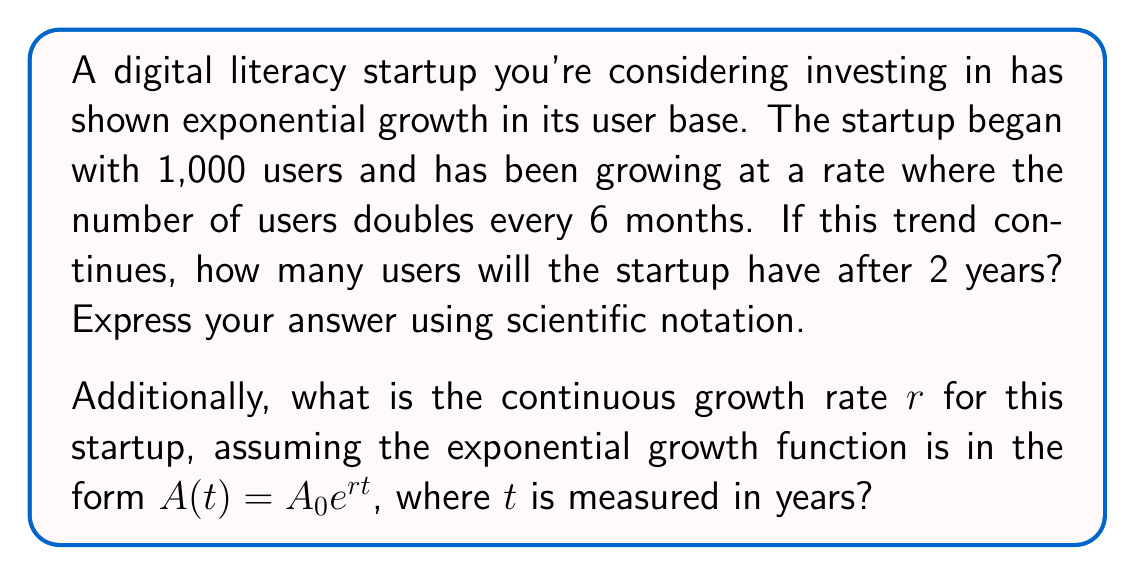Show me your answer to this math problem. Let's approach this problem step by step:

1) First, let's calculate the number of users after 2 years:
   - The number of users doubles every 6 months
   - In 2 years, there are 4 doubling periods

2) We can express this as:
   $$ 1000 \cdot 2^4 = 1000 \cdot 16 = 16,000 \text{ users} $$

3) In scientific notation, this is $1.6 \times 10^4$ users.

4) Now, for the continuous growth rate $r$:
   We know that $A(t) = A_0e^{rt}$, where:
   $A_0 = 1000$ (initial users)
   $A(2) = 16000$ (users after 2 years)
   $t = 2$ (time in years)

5) Substituting these values:
   $$ 16000 = 1000e^{2r} $$

6) Dividing both sides by 1000:
   $$ 16 = e^{2r} $$

7) Taking the natural log of both sides:
   $$ \ln(16) = 2r $$

8) Solving for $r$:
   $$ r = \frac{\ln(16)}{2} = \frac{\ln(2^4)}{2} = \frac{4\ln(2)}{2} = 2\ln(2) \approx 1.3863 $$

Thus, the continuous growth rate is approximately 1.3863 per year, or about 138.63% per year.
Answer: Number of users after 2 years: $1.6 \times 10^4$
Continuous growth rate: $r = 2\ln(2) \approx 1.3863$ per year 